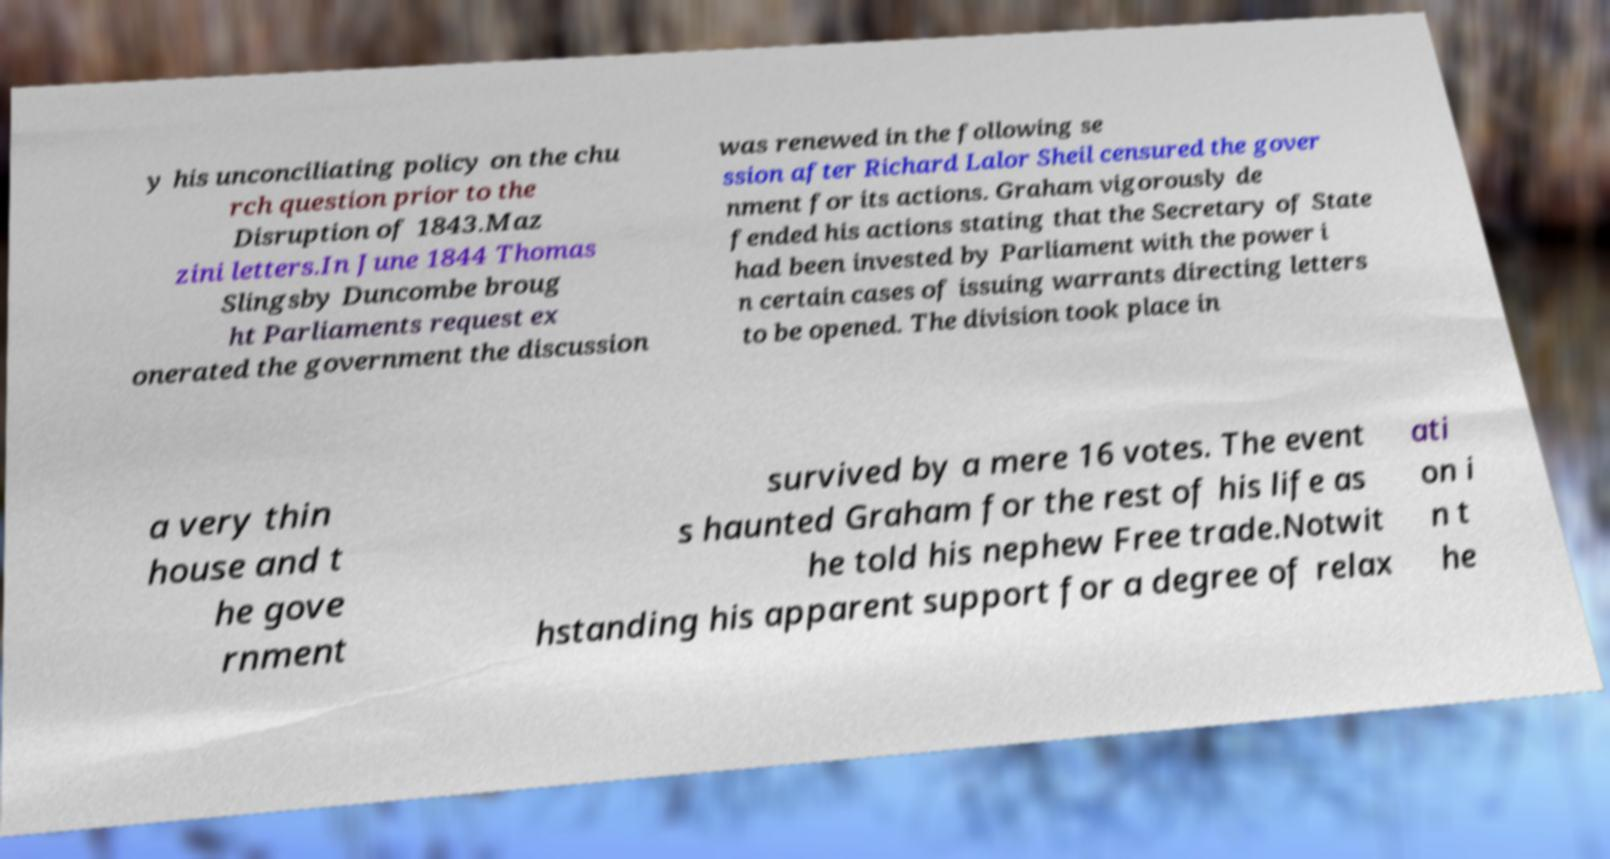Please read and relay the text visible in this image. What does it say? y his unconciliating policy on the chu rch question prior to the Disruption of 1843.Maz zini letters.In June 1844 Thomas Slingsby Duncombe broug ht Parliaments request ex onerated the government the discussion was renewed in the following se ssion after Richard Lalor Sheil censured the gover nment for its actions. Graham vigorously de fended his actions stating that the Secretary of State had been invested by Parliament with the power i n certain cases of issuing warrants directing letters to be opened. The division took place in a very thin house and t he gove rnment survived by a mere 16 votes. The event s haunted Graham for the rest of his life as he told his nephew Free trade.Notwit hstanding his apparent support for a degree of relax ati on i n t he 